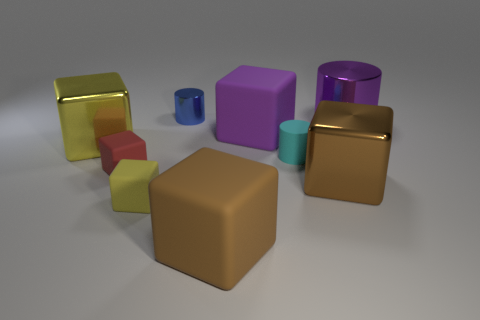What material is the object that is the same color as the big cylinder?
Give a very brief answer. Rubber. Are there any other tiny red blocks that have the same material as the small red cube?
Ensure brevity in your answer.  No. There is a cyan rubber cylinder; does it have the same size as the metal cylinder that is to the right of the blue object?
Your response must be concise. No. Are there any blocks that have the same color as the small metal object?
Ensure brevity in your answer.  No. Is the big yellow block made of the same material as the tiny yellow block?
Your response must be concise. No. There is a tiny yellow matte thing; how many small rubber blocks are behind it?
Your answer should be very brief. 1. The cylinder that is both behind the large yellow block and to the left of the big purple metal cylinder is made of what material?
Provide a succinct answer. Metal. How many red blocks are the same size as the yellow rubber block?
Make the answer very short. 1. There is a large shiny thing left of the metal cube on the right side of the small metallic object; what is its color?
Provide a short and direct response. Yellow. Are there any small cyan metal things?
Your answer should be very brief. No. 